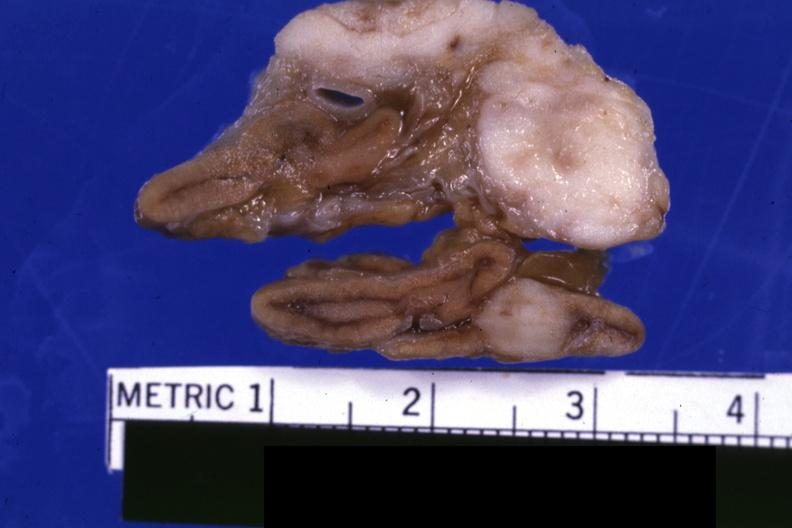what is present?
Answer the question using a single word or phrase. Carcinoma metastatic lung 